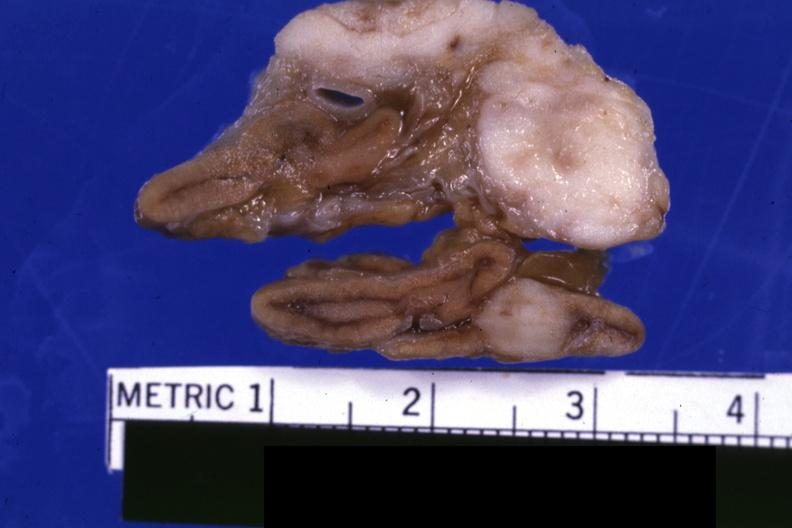what is present?
Answer the question using a single word or phrase. Carcinoma metastatic lung 